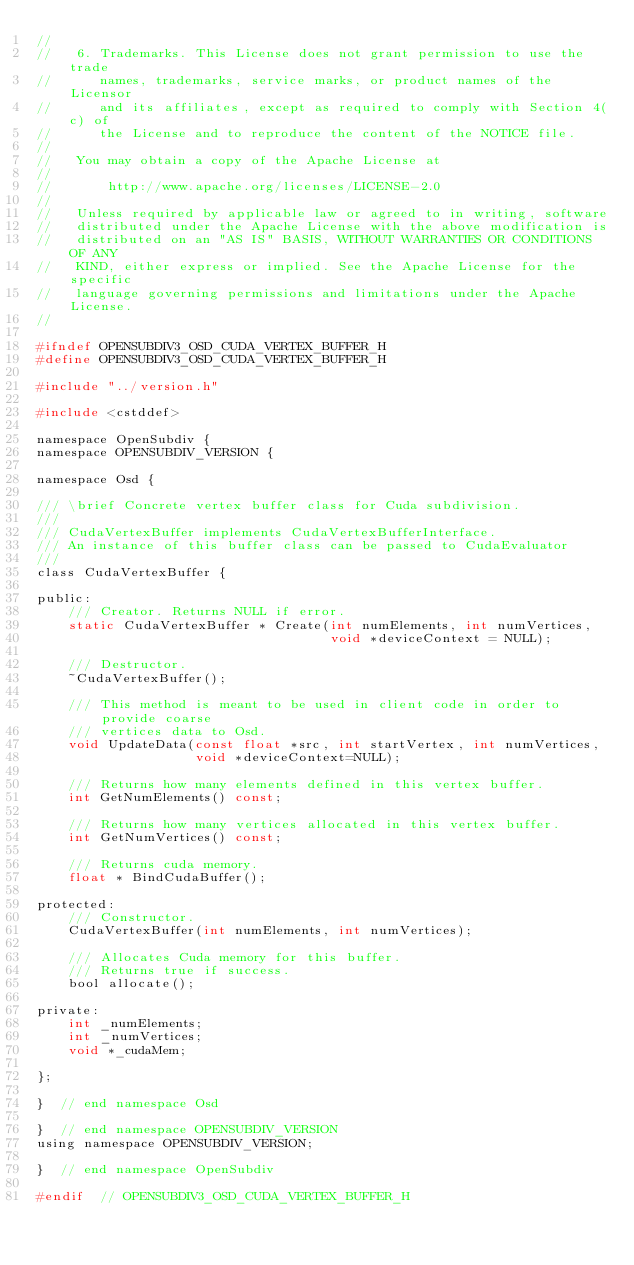<code> <loc_0><loc_0><loc_500><loc_500><_C_>//
//   6. Trademarks. This License does not grant permission to use the trade
//      names, trademarks, service marks, or product names of the Licensor
//      and its affiliates, except as required to comply with Section 4(c) of
//      the License and to reproduce the content of the NOTICE file.
//
//   You may obtain a copy of the Apache License at
//
//       http://www.apache.org/licenses/LICENSE-2.0
//
//   Unless required by applicable law or agreed to in writing, software
//   distributed under the Apache License with the above modification is
//   distributed on an "AS IS" BASIS, WITHOUT WARRANTIES OR CONDITIONS OF ANY
//   KIND, either express or implied. See the Apache License for the specific
//   language governing permissions and limitations under the Apache License.
//

#ifndef OPENSUBDIV3_OSD_CUDA_VERTEX_BUFFER_H
#define OPENSUBDIV3_OSD_CUDA_VERTEX_BUFFER_H

#include "../version.h"

#include <cstddef>

namespace OpenSubdiv {
namespace OPENSUBDIV_VERSION {

namespace Osd {

/// \brief Concrete vertex buffer class for Cuda subdivision.
///
/// CudaVertexBuffer implements CudaVertexBufferInterface.
/// An instance of this buffer class can be passed to CudaEvaluator
///
class CudaVertexBuffer {

public:
    /// Creator. Returns NULL if error.
    static CudaVertexBuffer * Create(int numElements, int numVertices,
                                     void *deviceContext = NULL);

    /// Destructor.
    ~CudaVertexBuffer();

    /// This method is meant to be used in client code in order to provide coarse
    /// vertices data to Osd.
    void UpdateData(const float *src, int startVertex, int numVertices,
                    void *deviceContext=NULL);

    /// Returns how many elements defined in this vertex buffer.
    int GetNumElements() const;

    /// Returns how many vertices allocated in this vertex buffer.
    int GetNumVertices() const;

    /// Returns cuda memory.
    float * BindCudaBuffer();

protected:
    /// Constructor.
    CudaVertexBuffer(int numElements, int numVertices);

    /// Allocates Cuda memory for this buffer.
    /// Returns true if success.
    bool allocate();

private:
    int _numElements;
    int _numVertices;
    void *_cudaMem;

};

}  // end namespace Osd

}  // end namespace OPENSUBDIV_VERSION
using namespace OPENSUBDIV_VERSION;

}  // end namespace OpenSubdiv

#endif  // OPENSUBDIV3_OSD_CUDA_VERTEX_BUFFER_H
</code> 